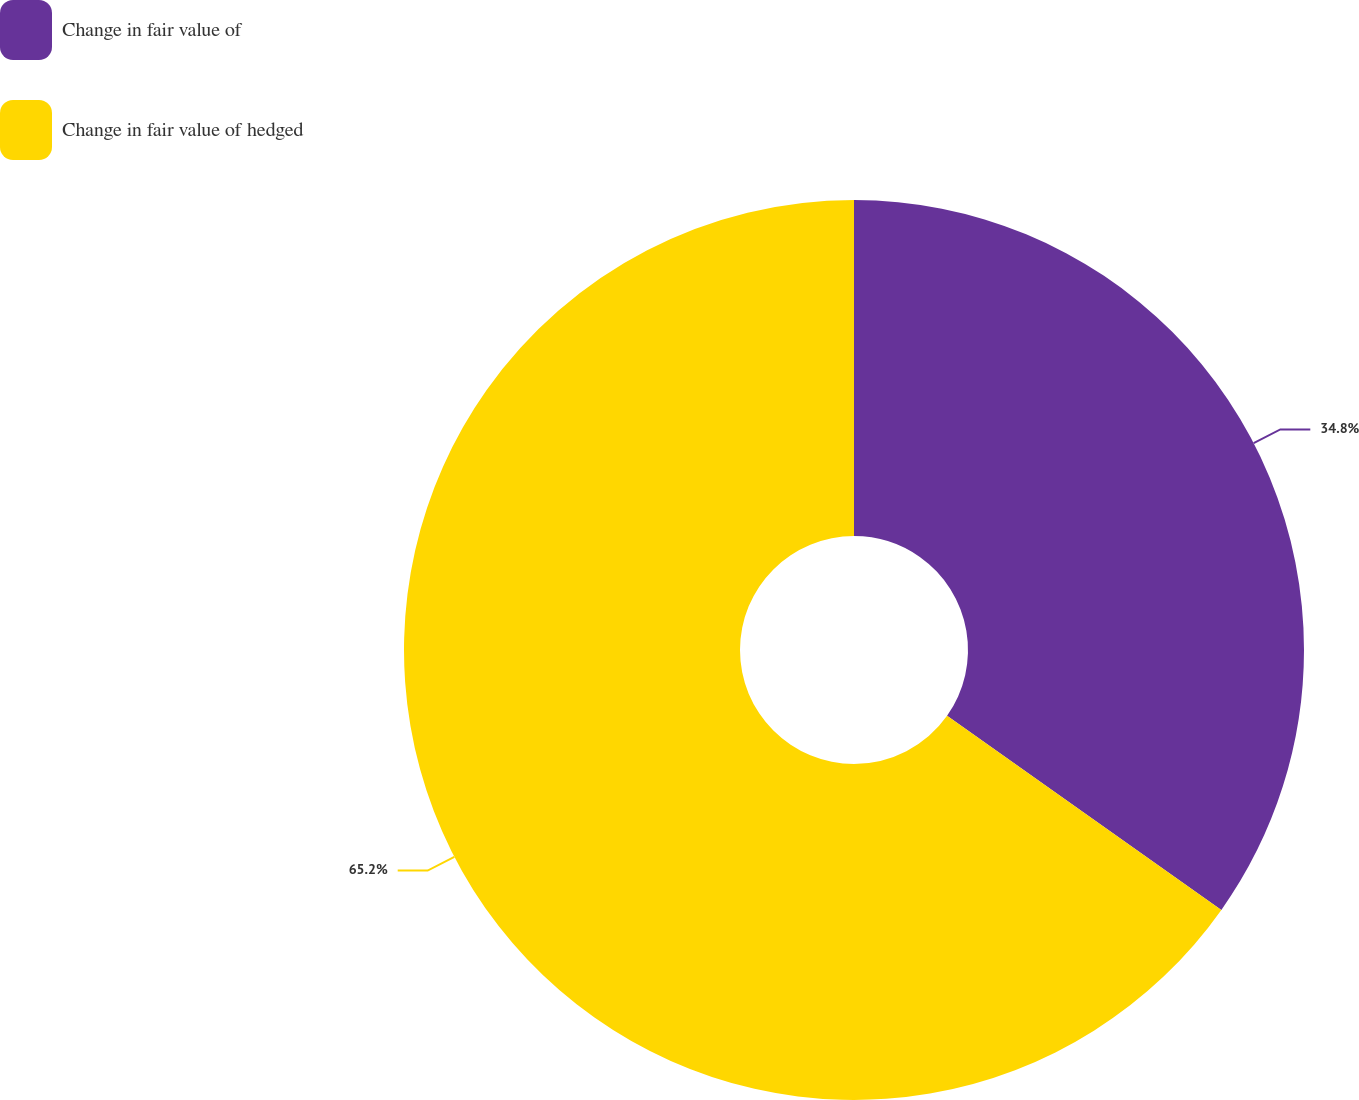<chart> <loc_0><loc_0><loc_500><loc_500><pie_chart><fcel>Change in fair value of<fcel>Change in fair value of hedged<nl><fcel>34.8%<fcel>65.2%<nl></chart> 